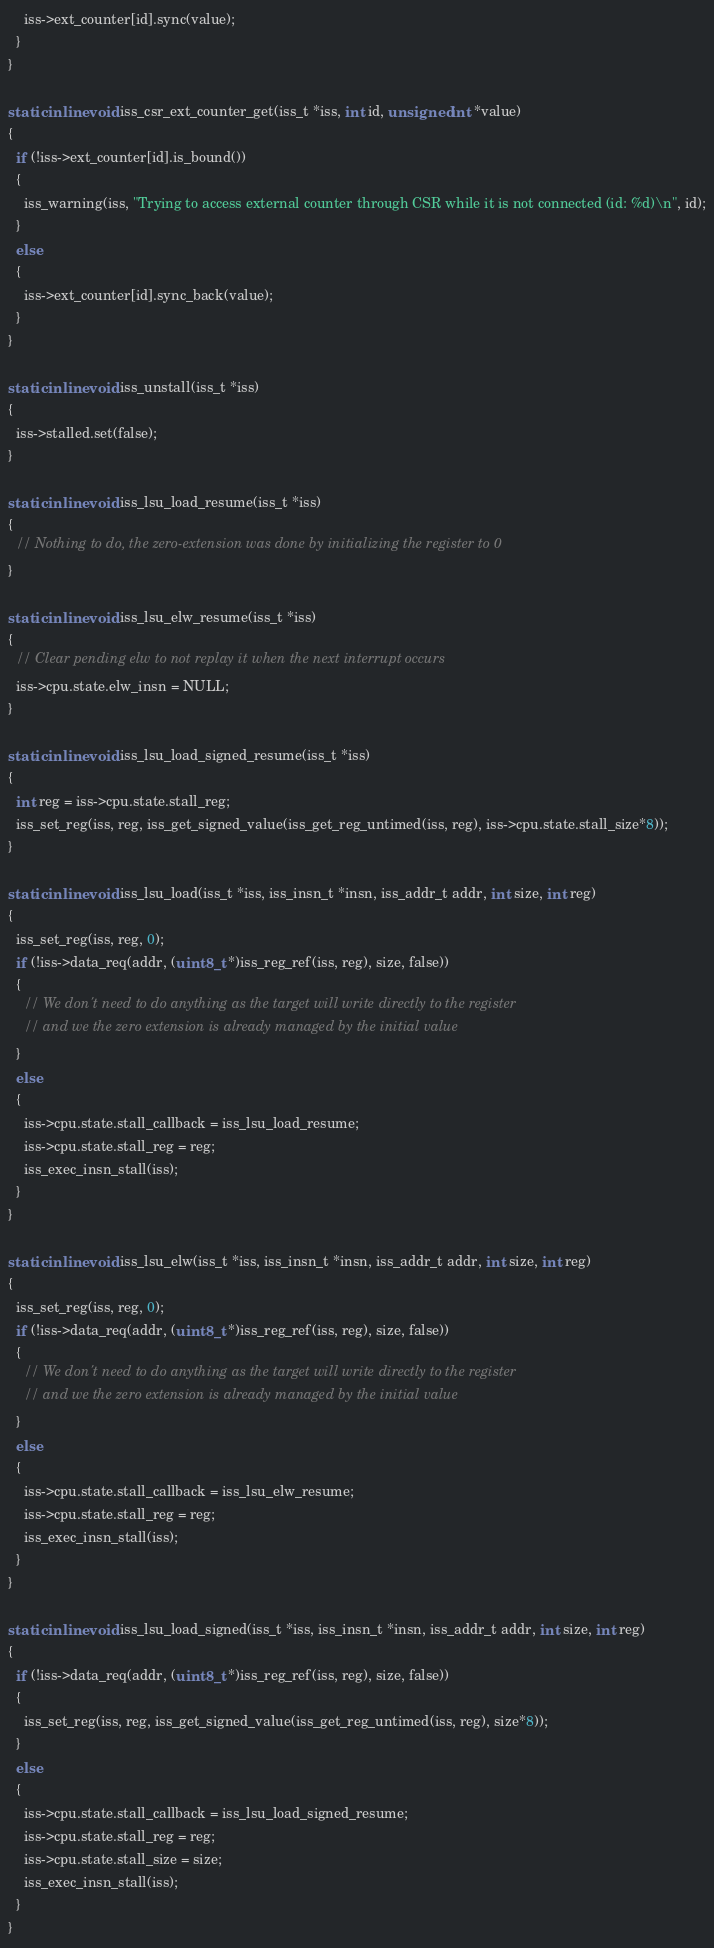Convert code to text. <code><loc_0><loc_0><loc_500><loc_500><_C++_>    iss->ext_counter[id].sync(value);
  }
}

static inline void iss_csr_ext_counter_get(iss_t *iss, int id, unsigned int *value)
{
  if (!iss->ext_counter[id].is_bound())
  {
    iss_warning(iss, "Trying to access external counter through CSR while it is not connected (id: %d)\n", id);
  }
  else
  {
    iss->ext_counter[id].sync_back(value);
  }
}

static inline void iss_unstall(iss_t *iss)
{
  iss->stalled.set(false);
}

static inline void iss_lsu_load_resume(iss_t *iss)
{
  // Nothing to do, the zero-extension was done by initializing the register to 0
}

static inline void iss_lsu_elw_resume(iss_t *iss)
{
  // Clear pending elw to not replay it when the next interrupt occurs
  iss->cpu.state.elw_insn = NULL;
}

static inline void iss_lsu_load_signed_resume(iss_t *iss)
{
  int reg = iss->cpu.state.stall_reg;
  iss_set_reg(iss, reg, iss_get_signed_value(iss_get_reg_untimed(iss, reg), iss->cpu.state.stall_size*8));
}

static inline void iss_lsu_load(iss_t *iss, iss_insn_t *insn, iss_addr_t addr, int size, int reg)
{
  iss_set_reg(iss, reg, 0);
  if (!iss->data_req(addr, (uint8_t *)iss_reg_ref(iss, reg), size, false))
  {
    // We don't need to do anything as the target will write directly to the register
    // and we the zero extension is already managed by the initial value
  }
  else
  {
    iss->cpu.state.stall_callback = iss_lsu_load_resume;
    iss->cpu.state.stall_reg = reg;
    iss_exec_insn_stall(iss);
  }
}

static inline void iss_lsu_elw(iss_t *iss, iss_insn_t *insn, iss_addr_t addr, int size, int reg)
{
  iss_set_reg(iss, reg, 0);
  if (!iss->data_req(addr, (uint8_t *)iss_reg_ref(iss, reg), size, false))
  {
    // We don't need to do anything as the target will write directly to the register
    // and we the zero extension is already managed by the initial value
  }
  else
  {
    iss->cpu.state.stall_callback = iss_lsu_elw_resume;
    iss->cpu.state.stall_reg = reg;
    iss_exec_insn_stall(iss);
  }
}

static inline void iss_lsu_load_signed(iss_t *iss, iss_insn_t *insn, iss_addr_t addr, int size, int reg)
{
  if (!iss->data_req(addr, (uint8_t *)iss_reg_ref(iss, reg), size, false))
  {
    iss_set_reg(iss, reg, iss_get_signed_value(iss_get_reg_untimed(iss, reg), size*8));
  }
  else
  {
    iss->cpu.state.stall_callback = iss_lsu_load_signed_resume;
    iss->cpu.state.stall_reg = reg;
    iss->cpu.state.stall_size = size;
    iss_exec_insn_stall(iss);
  }
}
</code> 